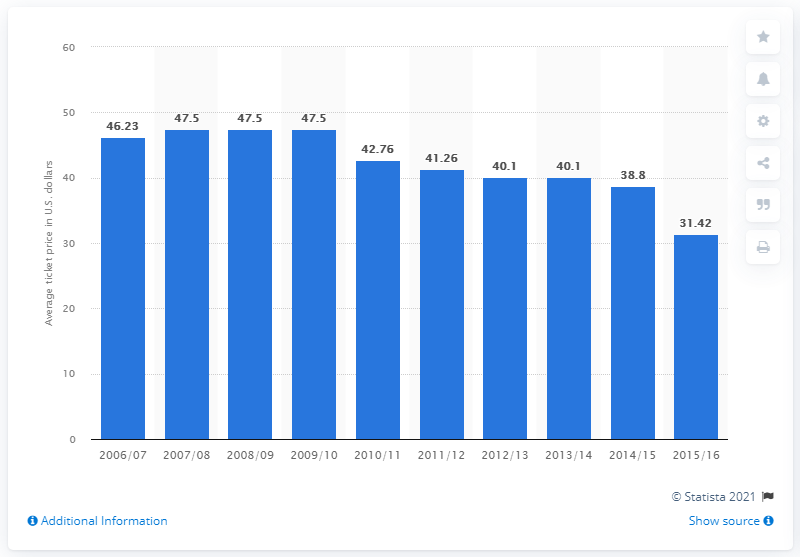List a handful of essential elements in this visual. The average ticket price for Detroit Pistons games in the 2006/2007 season was 46.23 U.S. dollars. 